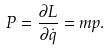<formula> <loc_0><loc_0><loc_500><loc_500>P = \frac { \partial L } { \partial \dot { q } } = m p .</formula> 